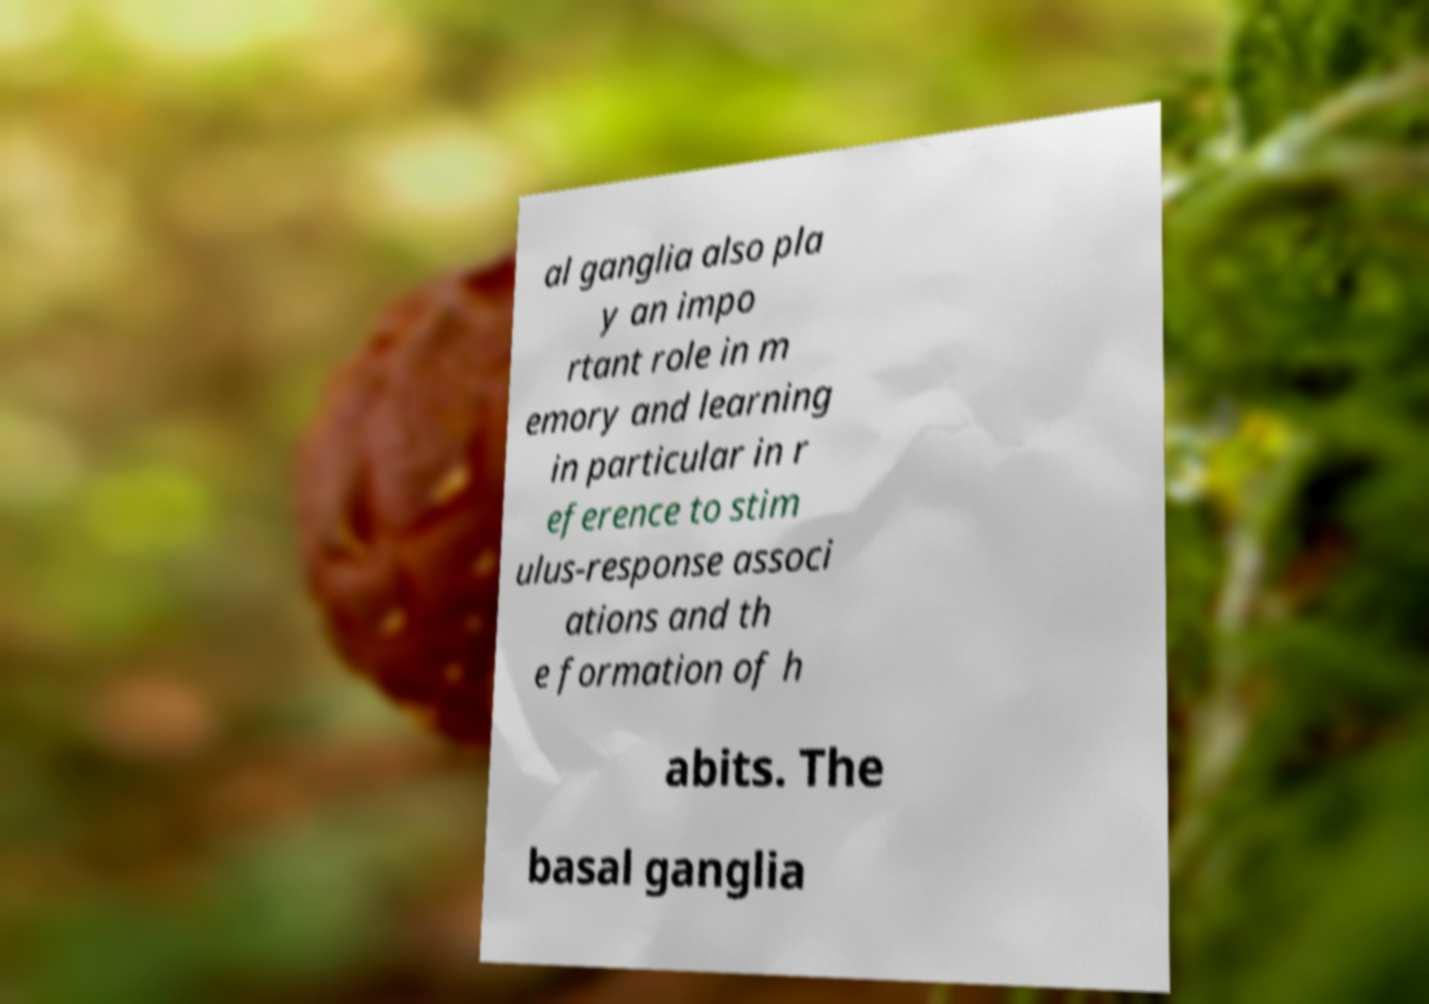I need the written content from this picture converted into text. Can you do that? al ganglia also pla y an impo rtant role in m emory and learning in particular in r eference to stim ulus-response associ ations and th e formation of h abits. The basal ganglia 